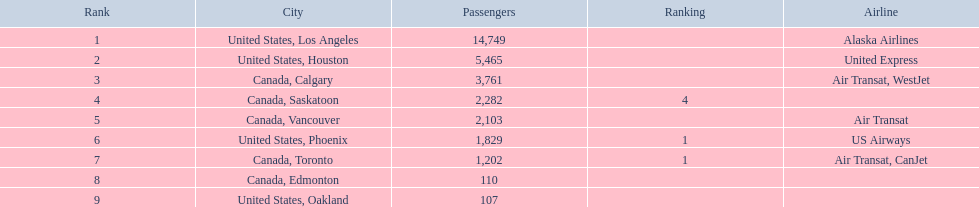To which cities do the planes journey? United States, Los Angeles, United States, Houston, Canada, Calgary, Canada, Saskatoon, Canada, Vancouver, United States, Phoenix, Canada, Toronto, Canada, Edmonton, United States, Oakland. How many folks are en route to phoenix, arizona? 1,829. 